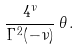Convert formula to latex. <formula><loc_0><loc_0><loc_500><loc_500>\frac { 4 ^ { \nu } } { \Gamma ^ { 2 } ( - \nu ) } \, \theta \, .</formula> 